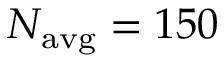Convert formula to latex. <formula><loc_0><loc_0><loc_500><loc_500>N _ { a v g } = 1 5 0</formula> 